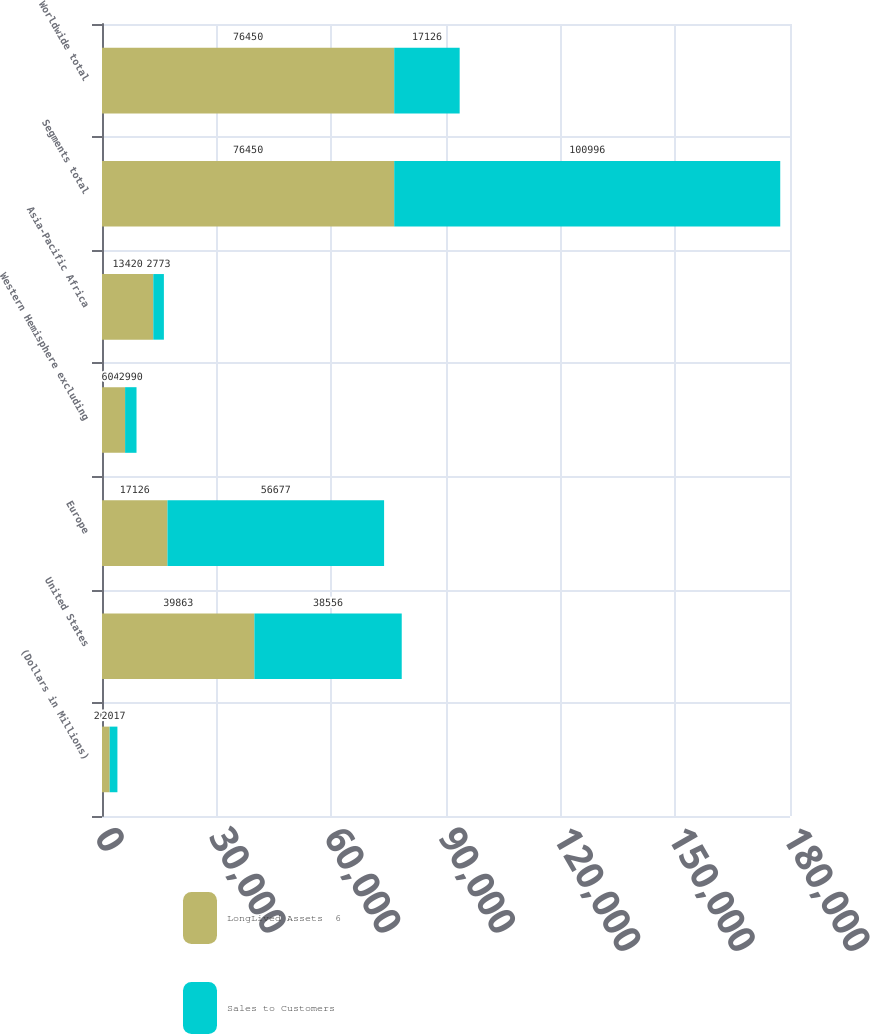Convert chart. <chart><loc_0><loc_0><loc_500><loc_500><stacked_bar_chart><ecel><fcel>(Dollars in Millions)<fcel>United States<fcel>Europe<fcel>Western Hemisphere excluding<fcel>Asia-Pacific Africa<fcel>Segments total<fcel>Worldwide total<nl><fcel>LongLived Assets  6<fcel>2017<fcel>39863<fcel>17126<fcel>6041<fcel>13420<fcel>76450<fcel>76450<nl><fcel>Sales to Customers<fcel>2017<fcel>38556<fcel>56677<fcel>2990<fcel>2773<fcel>100996<fcel>17126<nl></chart> 